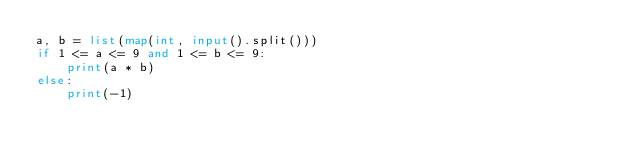<code> <loc_0><loc_0><loc_500><loc_500><_Python_>a, b = list(map(int, input().split()))
if 1 <= a <= 9 and 1 <= b <= 9:
    print(a * b)
else:
    print(-1)
</code> 